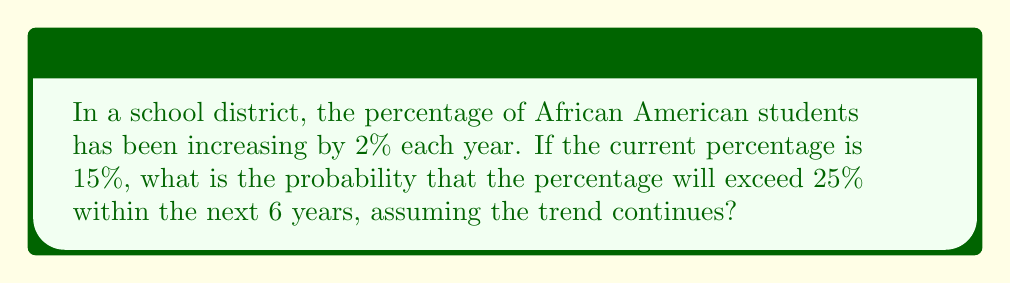Could you help me with this problem? Let's approach this step-by-step:

1) First, we need to determine how many years it would take for the percentage to exceed 25%.

   Let $x$ be the number of years:
   $15 + 2x > 25$
   $2x > 10$
   $x > 5$

   So, it would take more than 5 years to exceed 25%.

2) Now, we need to determine the probability of this happening within 6 years.

3) In this case, it's a certainty that it will happen in the 6th year if it hasn't happened before.

4) We can calculate the exact percentage after 6 years:
   $15 + (2 * 6) = 27\%$

5) Since 27% > 25%, and this is a deterministic process (not random), the probability is 1.

This problem demonstrates how demographic changes can be projected over time, which is relevant to understanding the changing composition of student populations in schools.
Answer: 1 